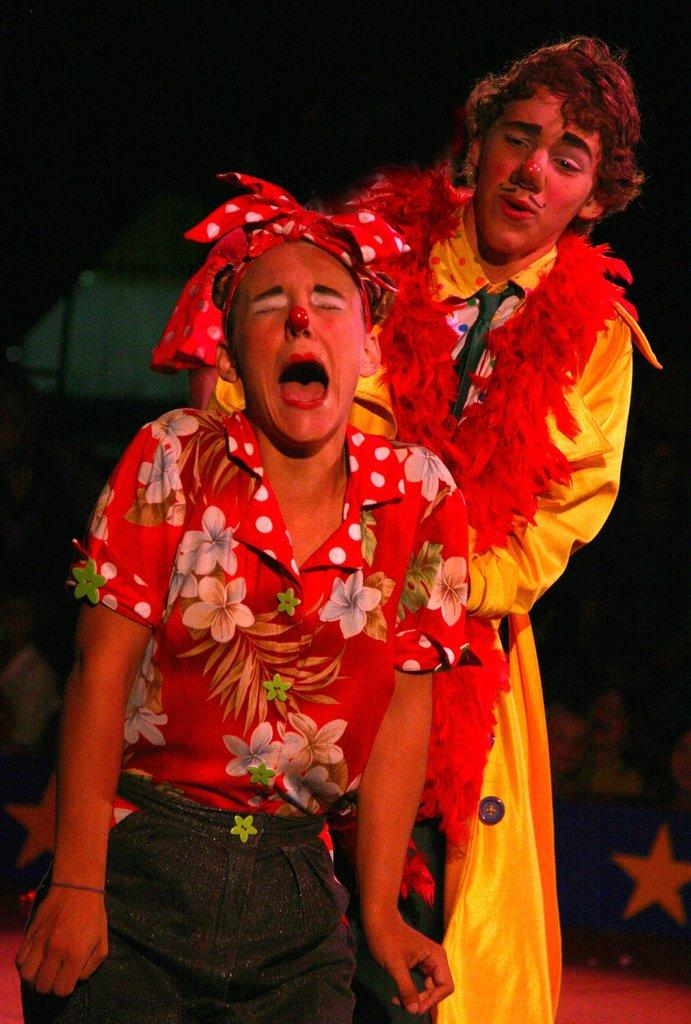How many people are present in the image? There are two persons in the image. What accessories are worn by the persons in the image? One person is wearing a headband, and the other person is wearing a garland. Can you describe the background of the image? The background of the image is blurred. Are there any other people visible in the image? Yes, there are a few people in the background of the image. What type of silk material is draped over the truck in the image? There is no truck or silk material present in the image. What kind of shoe is the person wearing on the left side of the image? There is no shoe visible in the image; only the persons' heads and accessories are shown. 